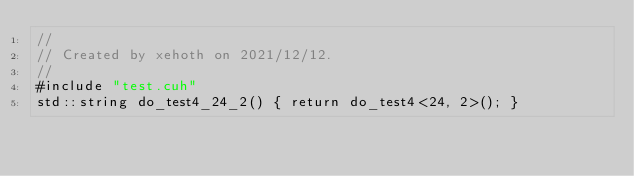Convert code to text. <code><loc_0><loc_0><loc_500><loc_500><_Cuda_>//
// Created by xehoth on 2021/12/12.
//
#include "test.cuh"
std::string do_test4_24_2() { return do_test4<24, 2>(); }
</code> 